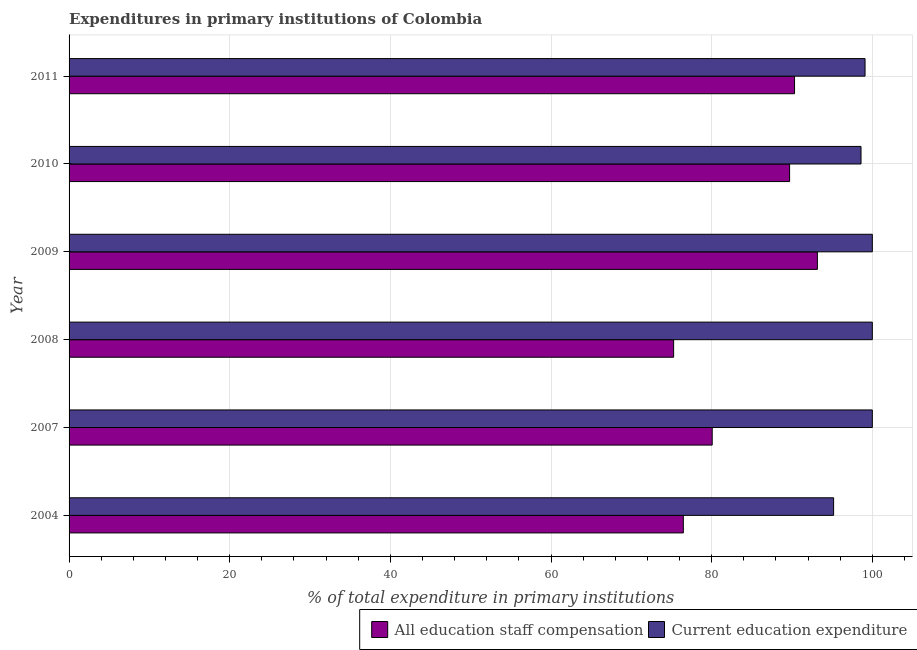Are the number of bars per tick equal to the number of legend labels?
Ensure brevity in your answer.  Yes. How many bars are there on the 1st tick from the bottom?
Your response must be concise. 2. What is the label of the 5th group of bars from the top?
Your answer should be very brief. 2007. Across all years, what is the maximum expenditure in staff compensation?
Your answer should be very brief. 93.16. Across all years, what is the minimum expenditure in education?
Ensure brevity in your answer.  95.18. In which year was the expenditure in education minimum?
Your answer should be very brief. 2004. What is the total expenditure in staff compensation in the graph?
Your answer should be very brief. 504.98. What is the difference between the expenditure in education in 2008 and that in 2009?
Ensure brevity in your answer.  0. What is the difference between the expenditure in staff compensation in 2011 and the expenditure in education in 2009?
Your answer should be compact. -9.68. What is the average expenditure in staff compensation per year?
Your answer should be very brief. 84.16. In the year 2011, what is the difference between the expenditure in education and expenditure in staff compensation?
Your answer should be compact. 8.78. In how many years, is the expenditure in education greater than 44 %?
Make the answer very short. 6. What is the difference between the highest and the second highest expenditure in education?
Ensure brevity in your answer.  0. What is the difference between the highest and the lowest expenditure in education?
Keep it short and to the point. 4.82. What does the 2nd bar from the top in 2010 represents?
Keep it short and to the point. All education staff compensation. What does the 2nd bar from the bottom in 2008 represents?
Your answer should be very brief. Current education expenditure. How many bars are there?
Provide a short and direct response. 12. How many years are there in the graph?
Your response must be concise. 6. Are the values on the major ticks of X-axis written in scientific E-notation?
Give a very brief answer. No. Does the graph contain any zero values?
Provide a succinct answer. No. Does the graph contain grids?
Make the answer very short. Yes. What is the title of the graph?
Your response must be concise. Expenditures in primary institutions of Colombia. Does "Arms imports" appear as one of the legend labels in the graph?
Give a very brief answer. No. What is the label or title of the X-axis?
Provide a short and direct response. % of total expenditure in primary institutions. What is the label or title of the Y-axis?
Provide a succinct answer. Year. What is the % of total expenditure in primary institutions of All education staff compensation in 2004?
Your response must be concise. 76.47. What is the % of total expenditure in primary institutions of Current education expenditure in 2004?
Your answer should be compact. 95.18. What is the % of total expenditure in primary institutions of All education staff compensation in 2007?
Your answer should be compact. 80.07. What is the % of total expenditure in primary institutions of Current education expenditure in 2007?
Your answer should be very brief. 100. What is the % of total expenditure in primary institutions of All education staff compensation in 2008?
Your response must be concise. 75.26. What is the % of total expenditure in primary institutions in All education staff compensation in 2009?
Ensure brevity in your answer.  93.16. What is the % of total expenditure in primary institutions in All education staff compensation in 2010?
Your response must be concise. 89.7. What is the % of total expenditure in primary institutions of Current education expenditure in 2010?
Keep it short and to the point. 98.59. What is the % of total expenditure in primary institutions of All education staff compensation in 2011?
Offer a terse response. 90.32. What is the % of total expenditure in primary institutions of Current education expenditure in 2011?
Make the answer very short. 99.09. Across all years, what is the maximum % of total expenditure in primary institutions of All education staff compensation?
Your response must be concise. 93.16. Across all years, what is the maximum % of total expenditure in primary institutions in Current education expenditure?
Your response must be concise. 100. Across all years, what is the minimum % of total expenditure in primary institutions of All education staff compensation?
Make the answer very short. 75.26. Across all years, what is the minimum % of total expenditure in primary institutions of Current education expenditure?
Provide a short and direct response. 95.18. What is the total % of total expenditure in primary institutions of All education staff compensation in the graph?
Provide a succinct answer. 504.98. What is the total % of total expenditure in primary institutions in Current education expenditure in the graph?
Your answer should be very brief. 592.86. What is the difference between the % of total expenditure in primary institutions of All education staff compensation in 2004 and that in 2007?
Offer a terse response. -3.6. What is the difference between the % of total expenditure in primary institutions in Current education expenditure in 2004 and that in 2007?
Ensure brevity in your answer.  -4.82. What is the difference between the % of total expenditure in primary institutions in All education staff compensation in 2004 and that in 2008?
Your answer should be very brief. 1.21. What is the difference between the % of total expenditure in primary institutions of Current education expenditure in 2004 and that in 2008?
Your answer should be very brief. -4.82. What is the difference between the % of total expenditure in primary institutions in All education staff compensation in 2004 and that in 2009?
Your answer should be compact. -16.69. What is the difference between the % of total expenditure in primary institutions in Current education expenditure in 2004 and that in 2009?
Ensure brevity in your answer.  -4.82. What is the difference between the % of total expenditure in primary institutions of All education staff compensation in 2004 and that in 2010?
Provide a succinct answer. -13.23. What is the difference between the % of total expenditure in primary institutions in Current education expenditure in 2004 and that in 2010?
Your answer should be very brief. -3.41. What is the difference between the % of total expenditure in primary institutions in All education staff compensation in 2004 and that in 2011?
Provide a succinct answer. -13.85. What is the difference between the % of total expenditure in primary institutions of Current education expenditure in 2004 and that in 2011?
Provide a succinct answer. -3.91. What is the difference between the % of total expenditure in primary institutions in All education staff compensation in 2007 and that in 2008?
Your answer should be very brief. 4.8. What is the difference between the % of total expenditure in primary institutions in Current education expenditure in 2007 and that in 2008?
Your answer should be compact. 0. What is the difference between the % of total expenditure in primary institutions in All education staff compensation in 2007 and that in 2009?
Your answer should be very brief. -13.09. What is the difference between the % of total expenditure in primary institutions in All education staff compensation in 2007 and that in 2010?
Your response must be concise. -9.64. What is the difference between the % of total expenditure in primary institutions in Current education expenditure in 2007 and that in 2010?
Provide a short and direct response. 1.41. What is the difference between the % of total expenditure in primary institutions of All education staff compensation in 2007 and that in 2011?
Provide a succinct answer. -10.25. What is the difference between the % of total expenditure in primary institutions of Current education expenditure in 2007 and that in 2011?
Provide a short and direct response. 0.91. What is the difference between the % of total expenditure in primary institutions of All education staff compensation in 2008 and that in 2009?
Give a very brief answer. -17.9. What is the difference between the % of total expenditure in primary institutions of All education staff compensation in 2008 and that in 2010?
Offer a very short reply. -14.44. What is the difference between the % of total expenditure in primary institutions in Current education expenditure in 2008 and that in 2010?
Your response must be concise. 1.41. What is the difference between the % of total expenditure in primary institutions of All education staff compensation in 2008 and that in 2011?
Your answer should be very brief. -15.05. What is the difference between the % of total expenditure in primary institutions of Current education expenditure in 2008 and that in 2011?
Provide a short and direct response. 0.91. What is the difference between the % of total expenditure in primary institutions of All education staff compensation in 2009 and that in 2010?
Your response must be concise. 3.46. What is the difference between the % of total expenditure in primary institutions of Current education expenditure in 2009 and that in 2010?
Your answer should be compact. 1.41. What is the difference between the % of total expenditure in primary institutions in All education staff compensation in 2009 and that in 2011?
Ensure brevity in your answer.  2.84. What is the difference between the % of total expenditure in primary institutions of Current education expenditure in 2009 and that in 2011?
Your answer should be very brief. 0.91. What is the difference between the % of total expenditure in primary institutions of All education staff compensation in 2010 and that in 2011?
Provide a succinct answer. -0.62. What is the difference between the % of total expenditure in primary institutions of Current education expenditure in 2010 and that in 2011?
Provide a short and direct response. -0.5. What is the difference between the % of total expenditure in primary institutions in All education staff compensation in 2004 and the % of total expenditure in primary institutions in Current education expenditure in 2007?
Make the answer very short. -23.53. What is the difference between the % of total expenditure in primary institutions of All education staff compensation in 2004 and the % of total expenditure in primary institutions of Current education expenditure in 2008?
Give a very brief answer. -23.53. What is the difference between the % of total expenditure in primary institutions of All education staff compensation in 2004 and the % of total expenditure in primary institutions of Current education expenditure in 2009?
Your answer should be very brief. -23.53. What is the difference between the % of total expenditure in primary institutions of All education staff compensation in 2004 and the % of total expenditure in primary institutions of Current education expenditure in 2010?
Your response must be concise. -22.12. What is the difference between the % of total expenditure in primary institutions of All education staff compensation in 2004 and the % of total expenditure in primary institutions of Current education expenditure in 2011?
Provide a short and direct response. -22.62. What is the difference between the % of total expenditure in primary institutions of All education staff compensation in 2007 and the % of total expenditure in primary institutions of Current education expenditure in 2008?
Give a very brief answer. -19.93. What is the difference between the % of total expenditure in primary institutions in All education staff compensation in 2007 and the % of total expenditure in primary institutions in Current education expenditure in 2009?
Your answer should be very brief. -19.93. What is the difference between the % of total expenditure in primary institutions in All education staff compensation in 2007 and the % of total expenditure in primary institutions in Current education expenditure in 2010?
Offer a terse response. -18.53. What is the difference between the % of total expenditure in primary institutions of All education staff compensation in 2007 and the % of total expenditure in primary institutions of Current education expenditure in 2011?
Your answer should be very brief. -19.03. What is the difference between the % of total expenditure in primary institutions in All education staff compensation in 2008 and the % of total expenditure in primary institutions in Current education expenditure in 2009?
Your response must be concise. -24.74. What is the difference between the % of total expenditure in primary institutions of All education staff compensation in 2008 and the % of total expenditure in primary institutions of Current education expenditure in 2010?
Give a very brief answer. -23.33. What is the difference between the % of total expenditure in primary institutions of All education staff compensation in 2008 and the % of total expenditure in primary institutions of Current education expenditure in 2011?
Keep it short and to the point. -23.83. What is the difference between the % of total expenditure in primary institutions of All education staff compensation in 2009 and the % of total expenditure in primary institutions of Current education expenditure in 2010?
Provide a succinct answer. -5.43. What is the difference between the % of total expenditure in primary institutions in All education staff compensation in 2009 and the % of total expenditure in primary institutions in Current education expenditure in 2011?
Offer a terse response. -5.93. What is the difference between the % of total expenditure in primary institutions in All education staff compensation in 2010 and the % of total expenditure in primary institutions in Current education expenditure in 2011?
Provide a succinct answer. -9.39. What is the average % of total expenditure in primary institutions of All education staff compensation per year?
Your answer should be compact. 84.16. What is the average % of total expenditure in primary institutions of Current education expenditure per year?
Offer a very short reply. 98.81. In the year 2004, what is the difference between the % of total expenditure in primary institutions in All education staff compensation and % of total expenditure in primary institutions in Current education expenditure?
Offer a terse response. -18.71. In the year 2007, what is the difference between the % of total expenditure in primary institutions of All education staff compensation and % of total expenditure in primary institutions of Current education expenditure?
Make the answer very short. -19.93. In the year 2008, what is the difference between the % of total expenditure in primary institutions of All education staff compensation and % of total expenditure in primary institutions of Current education expenditure?
Offer a terse response. -24.74. In the year 2009, what is the difference between the % of total expenditure in primary institutions of All education staff compensation and % of total expenditure in primary institutions of Current education expenditure?
Offer a very short reply. -6.84. In the year 2010, what is the difference between the % of total expenditure in primary institutions of All education staff compensation and % of total expenditure in primary institutions of Current education expenditure?
Your answer should be compact. -8.89. In the year 2011, what is the difference between the % of total expenditure in primary institutions of All education staff compensation and % of total expenditure in primary institutions of Current education expenditure?
Make the answer very short. -8.78. What is the ratio of the % of total expenditure in primary institutions in All education staff compensation in 2004 to that in 2007?
Give a very brief answer. 0.96. What is the ratio of the % of total expenditure in primary institutions in Current education expenditure in 2004 to that in 2007?
Provide a succinct answer. 0.95. What is the ratio of the % of total expenditure in primary institutions of All education staff compensation in 2004 to that in 2008?
Provide a short and direct response. 1.02. What is the ratio of the % of total expenditure in primary institutions of Current education expenditure in 2004 to that in 2008?
Make the answer very short. 0.95. What is the ratio of the % of total expenditure in primary institutions in All education staff compensation in 2004 to that in 2009?
Provide a short and direct response. 0.82. What is the ratio of the % of total expenditure in primary institutions of Current education expenditure in 2004 to that in 2009?
Make the answer very short. 0.95. What is the ratio of the % of total expenditure in primary institutions of All education staff compensation in 2004 to that in 2010?
Provide a short and direct response. 0.85. What is the ratio of the % of total expenditure in primary institutions of Current education expenditure in 2004 to that in 2010?
Your response must be concise. 0.97. What is the ratio of the % of total expenditure in primary institutions in All education staff compensation in 2004 to that in 2011?
Your response must be concise. 0.85. What is the ratio of the % of total expenditure in primary institutions of Current education expenditure in 2004 to that in 2011?
Make the answer very short. 0.96. What is the ratio of the % of total expenditure in primary institutions of All education staff compensation in 2007 to that in 2008?
Make the answer very short. 1.06. What is the ratio of the % of total expenditure in primary institutions in Current education expenditure in 2007 to that in 2008?
Make the answer very short. 1. What is the ratio of the % of total expenditure in primary institutions in All education staff compensation in 2007 to that in 2009?
Your response must be concise. 0.86. What is the ratio of the % of total expenditure in primary institutions in All education staff compensation in 2007 to that in 2010?
Give a very brief answer. 0.89. What is the ratio of the % of total expenditure in primary institutions of Current education expenditure in 2007 to that in 2010?
Offer a terse response. 1.01. What is the ratio of the % of total expenditure in primary institutions in All education staff compensation in 2007 to that in 2011?
Offer a terse response. 0.89. What is the ratio of the % of total expenditure in primary institutions of Current education expenditure in 2007 to that in 2011?
Offer a terse response. 1.01. What is the ratio of the % of total expenditure in primary institutions in All education staff compensation in 2008 to that in 2009?
Provide a succinct answer. 0.81. What is the ratio of the % of total expenditure in primary institutions in Current education expenditure in 2008 to that in 2009?
Give a very brief answer. 1. What is the ratio of the % of total expenditure in primary institutions of All education staff compensation in 2008 to that in 2010?
Provide a succinct answer. 0.84. What is the ratio of the % of total expenditure in primary institutions in Current education expenditure in 2008 to that in 2010?
Provide a short and direct response. 1.01. What is the ratio of the % of total expenditure in primary institutions in Current education expenditure in 2008 to that in 2011?
Offer a very short reply. 1.01. What is the ratio of the % of total expenditure in primary institutions of All education staff compensation in 2009 to that in 2010?
Make the answer very short. 1.04. What is the ratio of the % of total expenditure in primary institutions of Current education expenditure in 2009 to that in 2010?
Provide a succinct answer. 1.01. What is the ratio of the % of total expenditure in primary institutions in All education staff compensation in 2009 to that in 2011?
Your answer should be compact. 1.03. What is the ratio of the % of total expenditure in primary institutions in Current education expenditure in 2009 to that in 2011?
Offer a very short reply. 1.01. What is the ratio of the % of total expenditure in primary institutions of Current education expenditure in 2010 to that in 2011?
Keep it short and to the point. 0.99. What is the difference between the highest and the second highest % of total expenditure in primary institutions in All education staff compensation?
Provide a succinct answer. 2.84. What is the difference between the highest and the second highest % of total expenditure in primary institutions of Current education expenditure?
Provide a short and direct response. 0. What is the difference between the highest and the lowest % of total expenditure in primary institutions of All education staff compensation?
Your response must be concise. 17.9. What is the difference between the highest and the lowest % of total expenditure in primary institutions of Current education expenditure?
Your answer should be compact. 4.82. 